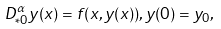<formula> <loc_0><loc_0><loc_500><loc_500>D _ { * 0 } ^ { \alpha } y ( x ) = f ( x , y ( x ) ) , y ( 0 ) = y _ { 0 } ,</formula> 